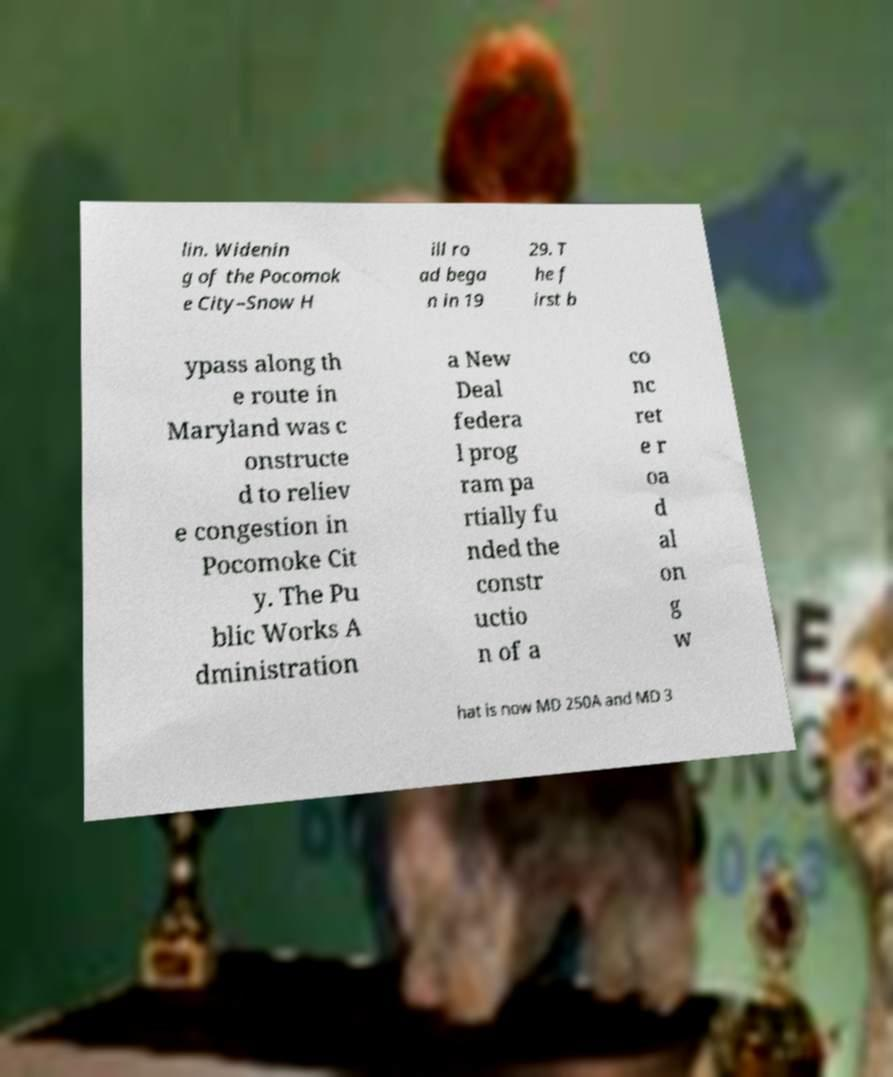For documentation purposes, I need the text within this image transcribed. Could you provide that? lin. Widenin g of the Pocomok e City–Snow H ill ro ad bega n in 19 29. T he f irst b ypass along th e route in Maryland was c onstructe d to reliev e congestion in Pocomoke Cit y. The Pu blic Works A dministration a New Deal federa l prog ram pa rtially fu nded the constr uctio n of a co nc ret e r oa d al on g w hat is now MD 250A and MD 3 